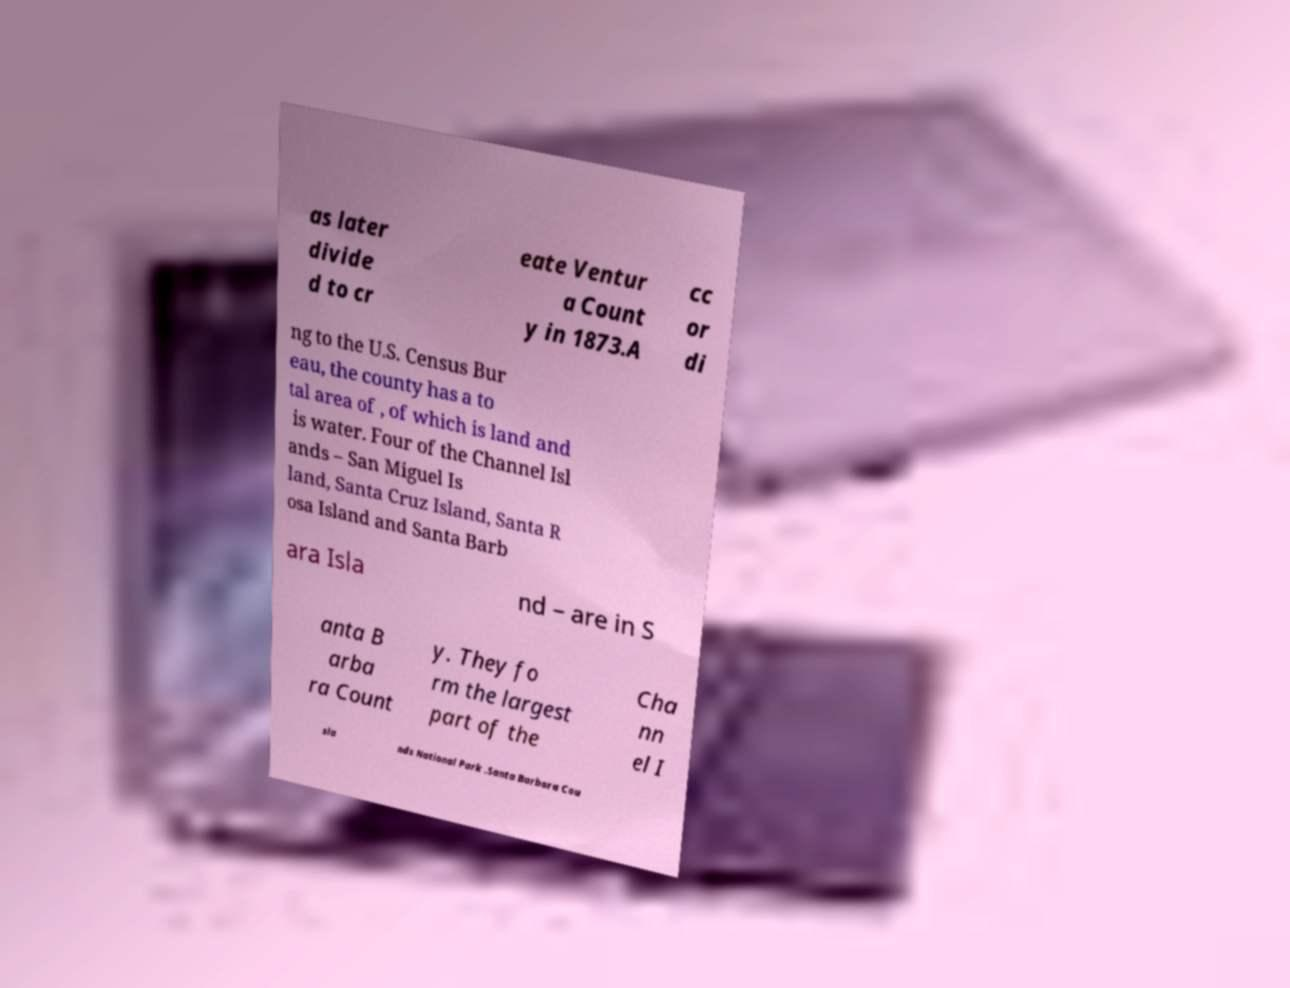What messages or text are displayed in this image? I need them in a readable, typed format. as later divide d to cr eate Ventur a Count y in 1873.A cc or di ng to the U.S. Census Bur eau, the county has a to tal area of , of which is land and is water. Four of the Channel Isl ands – San Miguel Is land, Santa Cruz Island, Santa R osa Island and Santa Barb ara Isla nd – are in S anta B arba ra Count y. They fo rm the largest part of the Cha nn el I sla nds National Park .Santa Barbara Cou 